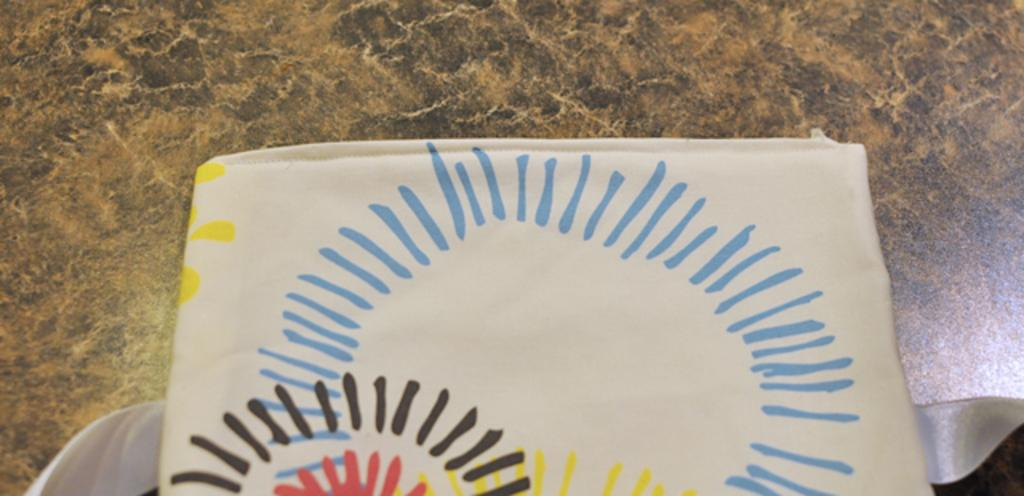What is on the floor in the image? There is cloth on the floor. What type of milk can be seen spilled on the cloth in the image? There is no milk present in the image; it only shows cloth on the floor. How many girls are sitting on the cloth in the image? There are no girls present in the image; it only shows cloth on the floor. 